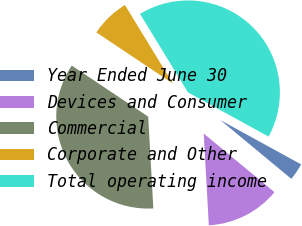<chart> <loc_0><loc_0><loc_500><loc_500><pie_chart><fcel>Year Ended June 30<fcel>Devices and Consumer<fcel>Commercial<fcel>Corporate and Other<fcel>Total operating income<nl><fcel>3.03%<fcel>13.1%<fcel>35.27%<fcel>6.9%<fcel>41.72%<nl></chart> 